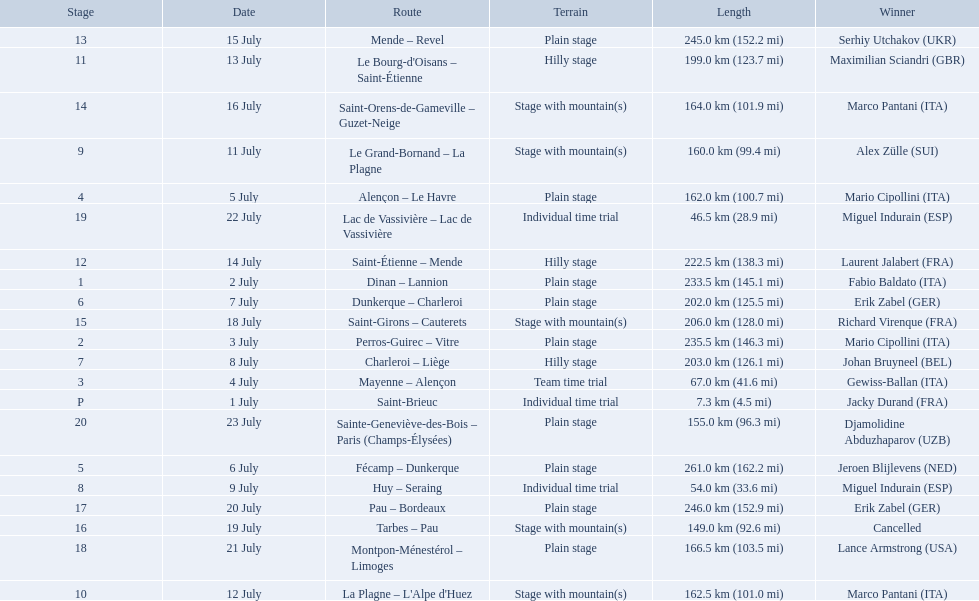What are the dates? 1 July, 2 July, 3 July, 4 July, 5 July, 6 July, 7 July, 8 July, 9 July, 11 July, 12 July, 13 July, 14 July, 15 July, 16 July, 18 July, 19 July, 20 July, 21 July, 22 July, 23 July. What is the length on 8 july? 203.0 km (126.1 mi). What were the dates of the 1995 tour de france? 1 July, 2 July, 3 July, 4 July, 5 July, 6 July, 7 July, 8 July, 9 July, 11 July, 12 July, 13 July, 14 July, 15 July, 16 July, 18 July, 19 July, 20 July, 21 July, 22 July, 23 July. What was the length for july 8th? 203.0 km (126.1 mi). 